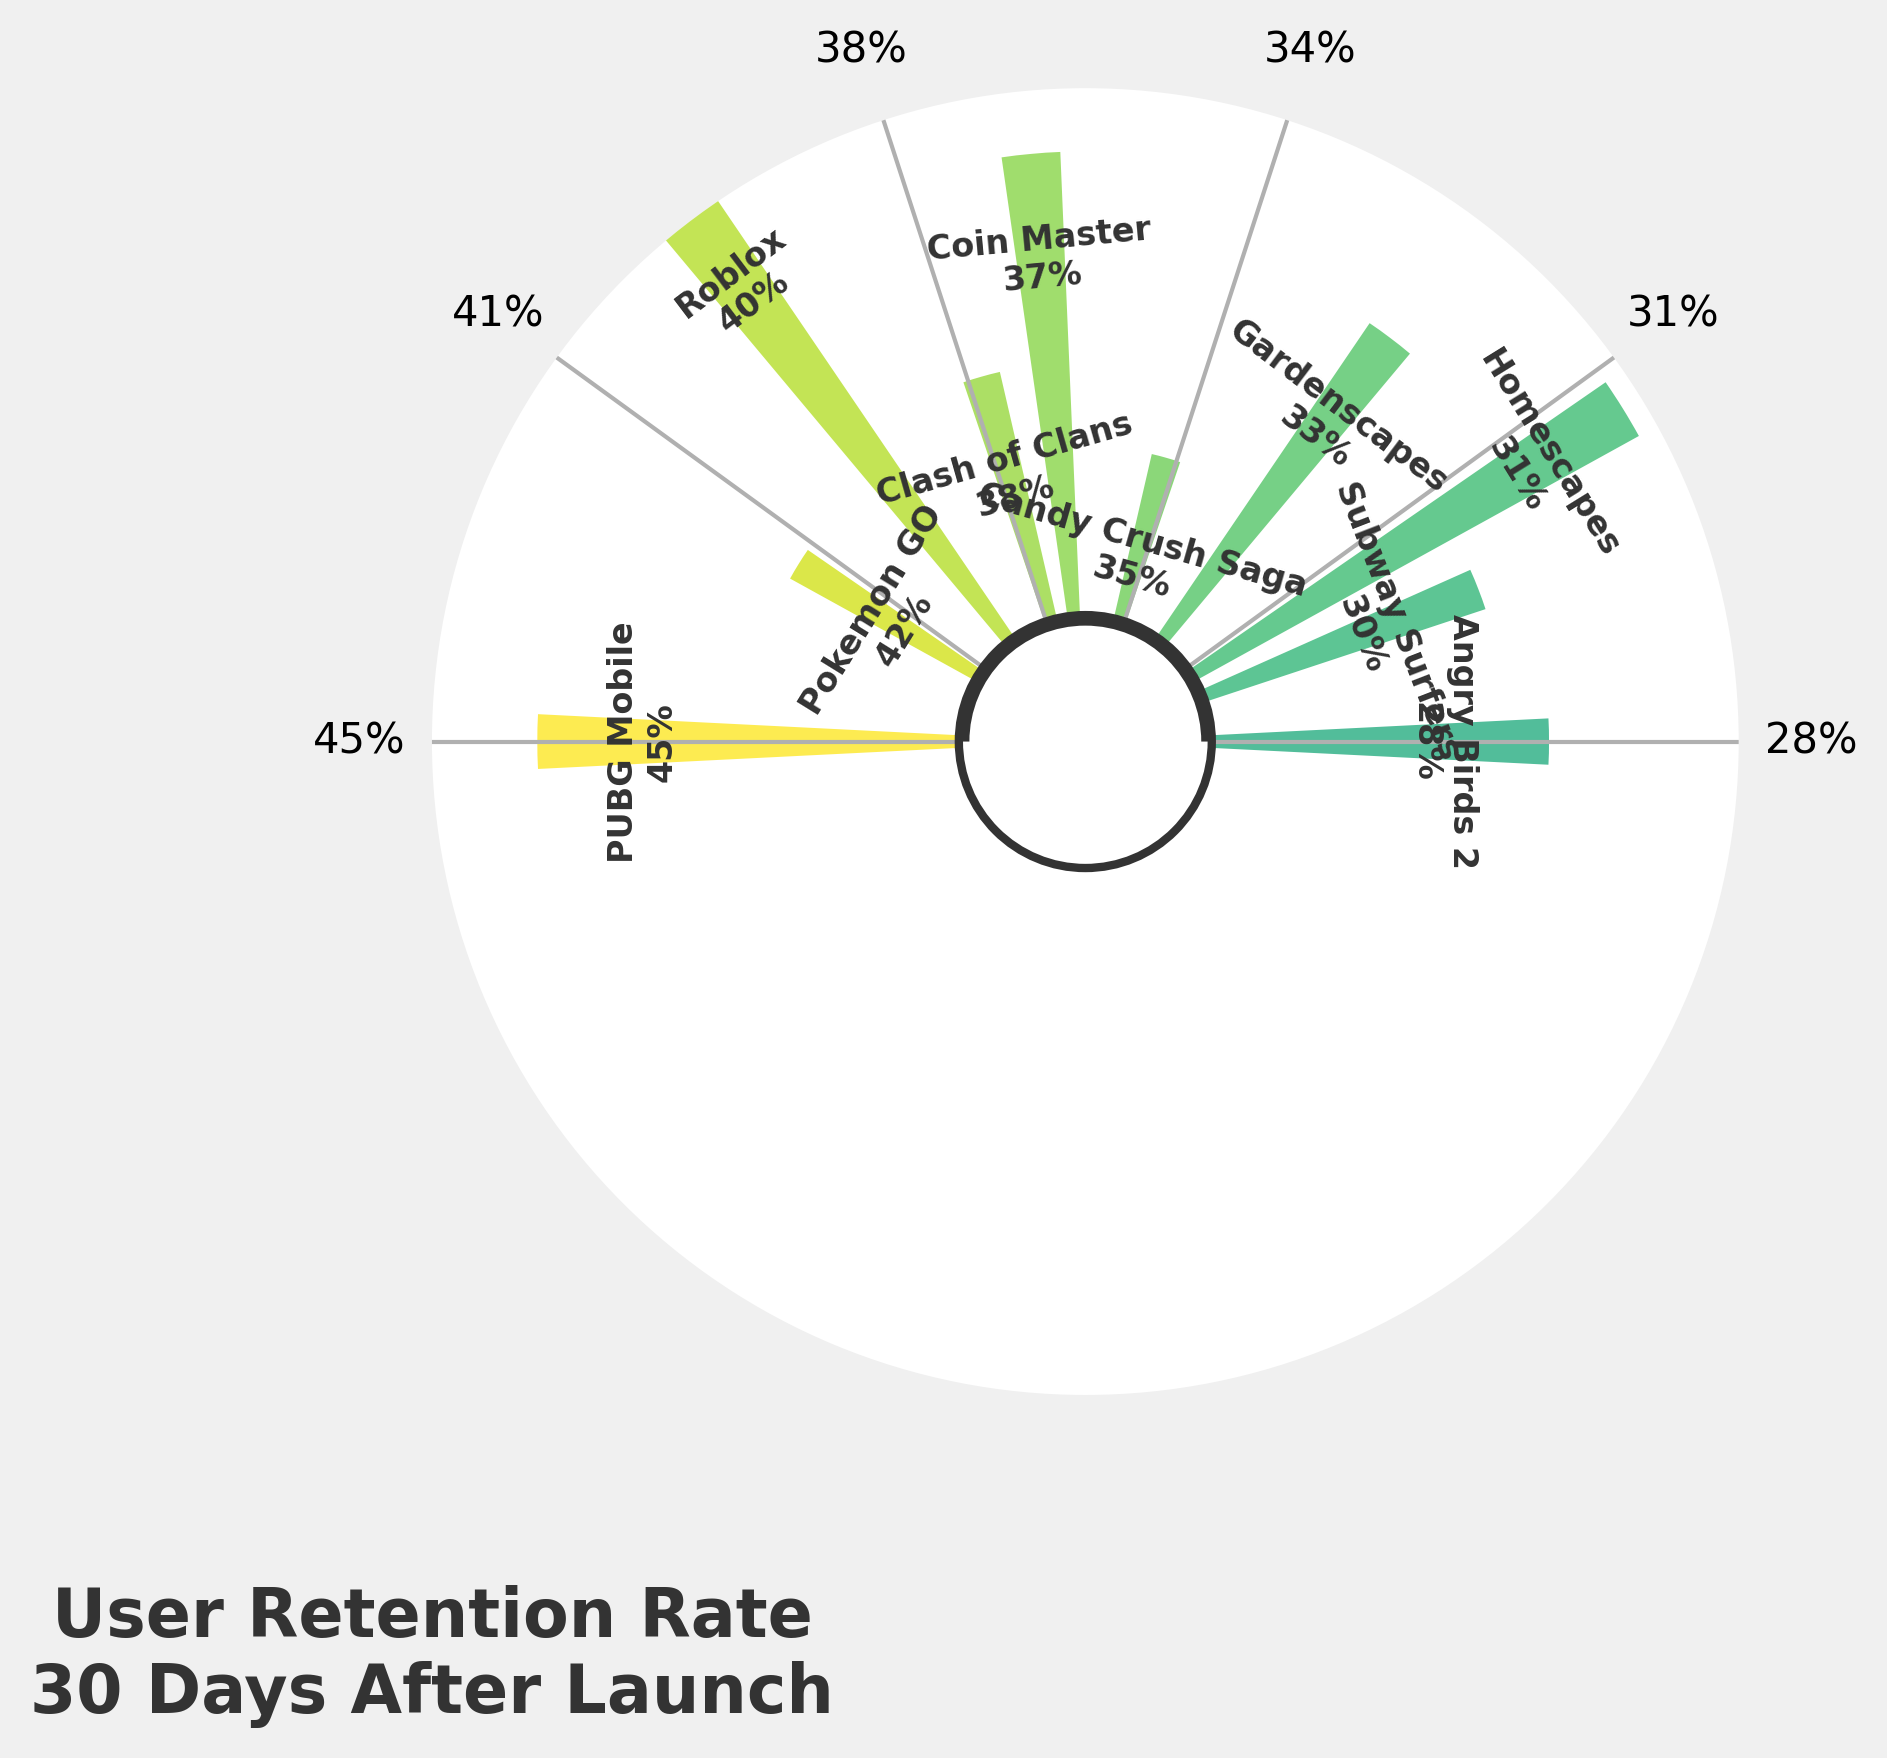What's the highest retention rate shown for the games? By looking at the figure, we identify the segment with the highest percentage label, which represents the maximum retention rate for the games.
Answer: 45% How many games have a retention rate greater than 35%? Count the number of segments where the retention rate label is greater than 35%.
Answer: 5 Which game has the lowest retention rate? Identify the segment with the lowest percentage label and check the corresponding game name.
Answer: Angry Birds 2 Find the average retention rate for the games listed. Sum the retention rates of all games and divide by the total number of games: (35 + 42 + 38 + 30 + 28 + 33 + 45 + 37 + 31 + 40)/10 = 35.9%
Answer: 35.9% What is the retention rate difference between Roblox and Subway Surfers? Find the retention rates of Roblox (40%) and Subway Surfers (30%) and calculate the difference: 40% - 30% = 10%
Answer: 10% Which two games have the closest retention rates? Compare retention rates to find games with the smallest difference, which are Clash of Clans (38%) and Coin Master (37%) with a difference of 1%.
Answer: Clash of Clans and Coin Master What is the median retention rate for the games? Arrange the retention rates in ascending order and find the middle value(s). Since there are 10 values, the median is the average of the 5th and 6th values: (35 + 37)/2 = 36%.
Answer: 36% How does the retention rate of PUBG Mobile compare to the retention rate of Angry Birds 2? Compare the retention rates of PUBG Mobile (45%) and Angry Birds 2 (28%). PUBG Mobile has a higher retention rate.
Answer: PUBG Mobile is higher What's the total retention rate sum for all games combined? Add the retention rates of all games: 35 + 42 + 38 + 30 + 28 + 33 + 45 + 37 + 31 + 40 = 359%
Answer: 359% Which game's retention rate falls exactly at the midpoint between the highest and lowest rates observed? Calculate the midpoint between the highest (45%) and lowest (28%) rates: (45 + 28)/2 = 36.5%. Gardenscapes (33%) or Coin Master (37%) are closest, but Coin Master is nearest to 36.5%.
Answer: Coin Master 